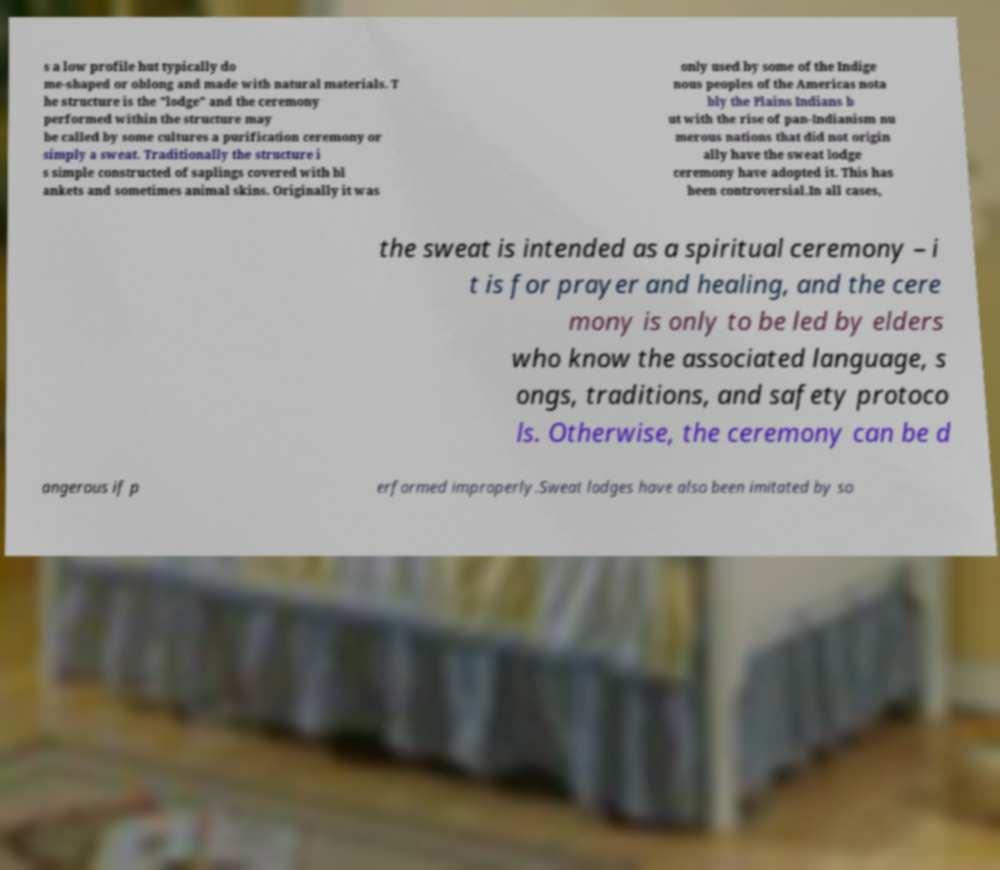What messages or text are displayed in this image? I need them in a readable, typed format. s a low profile hut typically do me-shaped or oblong and made with natural materials. T he structure is the "lodge" and the ceremony performed within the structure may be called by some cultures a purification ceremony or simply a sweat. Traditionally the structure i s simple constructed of saplings covered with bl ankets and sometimes animal skins. Originally it was only used by some of the Indige nous peoples of the Americas nota bly the Plains Indians b ut with the rise of pan-Indianism nu merous nations that did not origin ally have the sweat lodge ceremony have adopted it. This has been controversial.In all cases, the sweat is intended as a spiritual ceremony – i t is for prayer and healing, and the cere mony is only to be led by elders who know the associated language, s ongs, traditions, and safety protoco ls. Otherwise, the ceremony can be d angerous if p erformed improperly.Sweat lodges have also been imitated by so 